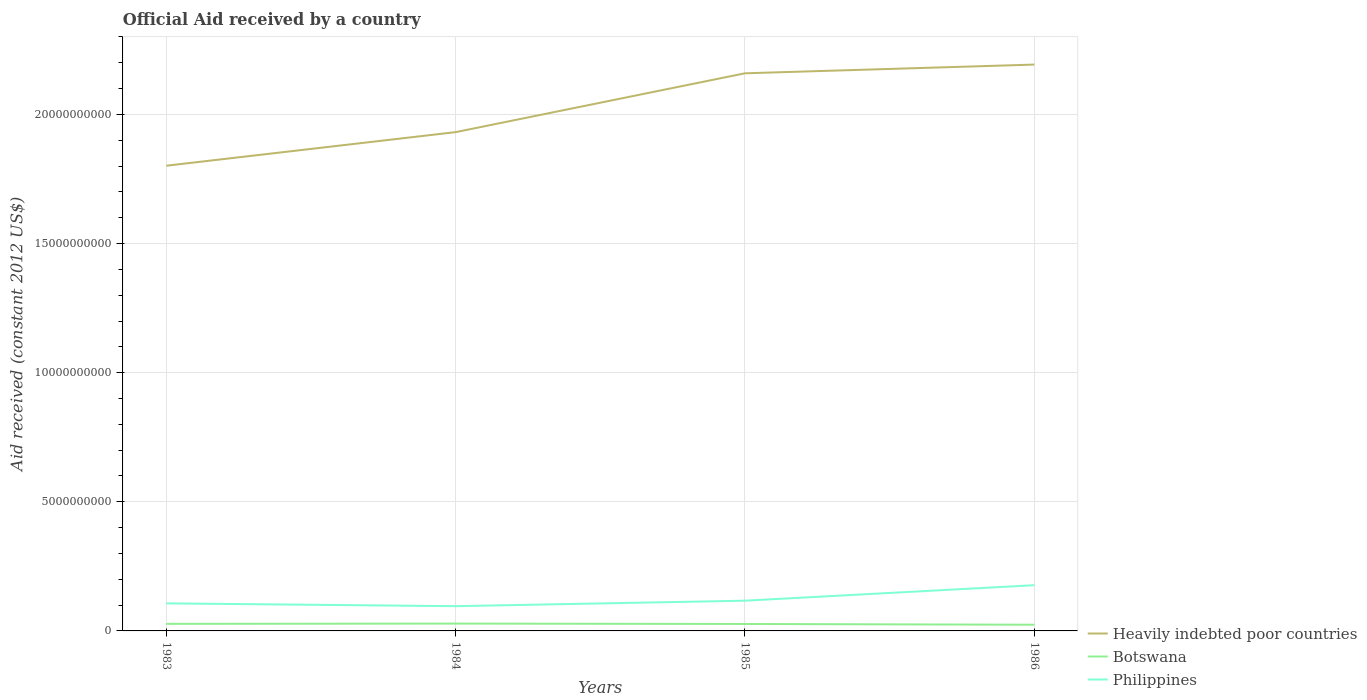Is the number of lines equal to the number of legend labels?
Give a very brief answer. Yes. Across all years, what is the maximum net official aid received in Heavily indebted poor countries?
Offer a terse response. 1.80e+1. What is the total net official aid received in Botswana in the graph?
Give a very brief answer. 3.48e+07. What is the difference between the highest and the second highest net official aid received in Philippines?
Keep it short and to the point. 8.12e+08. What is the difference between the highest and the lowest net official aid received in Heavily indebted poor countries?
Offer a very short reply. 2. What is the difference between two consecutive major ticks on the Y-axis?
Provide a short and direct response. 5.00e+09. Are the values on the major ticks of Y-axis written in scientific E-notation?
Offer a terse response. No. Does the graph contain any zero values?
Make the answer very short. No. Does the graph contain grids?
Your answer should be very brief. Yes. Where does the legend appear in the graph?
Provide a short and direct response. Bottom right. How many legend labels are there?
Your answer should be compact. 3. What is the title of the graph?
Offer a very short reply. Official Aid received by a country. Does "St. Martin (French part)" appear as one of the legend labels in the graph?
Make the answer very short. No. What is the label or title of the Y-axis?
Make the answer very short. Aid received (constant 2012 US$). What is the Aid received (constant 2012 US$) in Heavily indebted poor countries in 1983?
Your answer should be very brief. 1.80e+1. What is the Aid received (constant 2012 US$) in Botswana in 1983?
Provide a succinct answer. 2.74e+08. What is the Aid received (constant 2012 US$) of Philippines in 1983?
Offer a terse response. 1.07e+09. What is the Aid received (constant 2012 US$) of Heavily indebted poor countries in 1984?
Offer a terse response. 1.93e+1. What is the Aid received (constant 2012 US$) in Botswana in 1984?
Offer a very short reply. 2.84e+08. What is the Aid received (constant 2012 US$) in Philippines in 1984?
Provide a short and direct response. 9.58e+08. What is the Aid received (constant 2012 US$) in Heavily indebted poor countries in 1985?
Make the answer very short. 2.16e+1. What is the Aid received (constant 2012 US$) in Botswana in 1985?
Offer a terse response. 2.69e+08. What is the Aid received (constant 2012 US$) in Philippines in 1985?
Your answer should be very brief. 1.17e+09. What is the Aid received (constant 2012 US$) of Heavily indebted poor countries in 1986?
Offer a terse response. 2.19e+1. What is the Aid received (constant 2012 US$) in Botswana in 1986?
Ensure brevity in your answer.  2.39e+08. What is the Aid received (constant 2012 US$) in Philippines in 1986?
Provide a short and direct response. 1.77e+09. Across all years, what is the maximum Aid received (constant 2012 US$) of Heavily indebted poor countries?
Keep it short and to the point. 2.19e+1. Across all years, what is the maximum Aid received (constant 2012 US$) of Botswana?
Your answer should be compact. 2.84e+08. Across all years, what is the maximum Aid received (constant 2012 US$) in Philippines?
Give a very brief answer. 1.77e+09. Across all years, what is the minimum Aid received (constant 2012 US$) of Heavily indebted poor countries?
Your answer should be compact. 1.80e+1. Across all years, what is the minimum Aid received (constant 2012 US$) in Botswana?
Your response must be concise. 2.39e+08. Across all years, what is the minimum Aid received (constant 2012 US$) of Philippines?
Provide a succinct answer. 9.58e+08. What is the total Aid received (constant 2012 US$) in Heavily indebted poor countries in the graph?
Your answer should be compact. 8.08e+1. What is the total Aid received (constant 2012 US$) of Botswana in the graph?
Offer a terse response. 1.07e+09. What is the total Aid received (constant 2012 US$) of Philippines in the graph?
Your answer should be very brief. 4.97e+09. What is the difference between the Aid received (constant 2012 US$) in Heavily indebted poor countries in 1983 and that in 1984?
Make the answer very short. -1.30e+09. What is the difference between the Aid received (constant 2012 US$) in Botswana in 1983 and that in 1984?
Your response must be concise. -1.00e+07. What is the difference between the Aid received (constant 2012 US$) in Philippines in 1983 and that in 1984?
Make the answer very short. 1.09e+08. What is the difference between the Aid received (constant 2012 US$) in Heavily indebted poor countries in 1983 and that in 1985?
Make the answer very short. -3.58e+09. What is the difference between the Aid received (constant 2012 US$) in Botswana in 1983 and that in 1985?
Give a very brief answer. 4.75e+06. What is the difference between the Aid received (constant 2012 US$) in Philippines in 1983 and that in 1985?
Your answer should be compact. -1.03e+08. What is the difference between the Aid received (constant 2012 US$) of Heavily indebted poor countries in 1983 and that in 1986?
Give a very brief answer. -3.92e+09. What is the difference between the Aid received (constant 2012 US$) of Botswana in 1983 and that in 1986?
Ensure brevity in your answer.  3.48e+07. What is the difference between the Aid received (constant 2012 US$) of Philippines in 1983 and that in 1986?
Offer a terse response. -7.03e+08. What is the difference between the Aid received (constant 2012 US$) of Heavily indebted poor countries in 1984 and that in 1985?
Offer a very short reply. -2.28e+09. What is the difference between the Aid received (constant 2012 US$) in Botswana in 1984 and that in 1985?
Your answer should be very brief. 1.48e+07. What is the difference between the Aid received (constant 2012 US$) of Philippines in 1984 and that in 1985?
Make the answer very short. -2.12e+08. What is the difference between the Aid received (constant 2012 US$) of Heavily indebted poor countries in 1984 and that in 1986?
Your response must be concise. -2.62e+09. What is the difference between the Aid received (constant 2012 US$) of Botswana in 1984 and that in 1986?
Ensure brevity in your answer.  4.48e+07. What is the difference between the Aid received (constant 2012 US$) in Philippines in 1984 and that in 1986?
Ensure brevity in your answer.  -8.12e+08. What is the difference between the Aid received (constant 2012 US$) of Heavily indebted poor countries in 1985 and that in 1986?
Provide a succinct answer. -3.37e+08. What is the difference between the Aid received (constant 2012 US$) in Botswana in 1985 and that in 1986?
Make the answer very short. 3.01e+07. What is the difference between the Aid received (constant 2012 US$) of Philippines in 1985 and that in 1986?
Ensure brevity in your answer.  -6.00e+08. What is the difference between the Aid received (constant 2012 US$) in Heavily indebted poor countries in 1983 and the Aid received (constant 2012 US$) in Botswana in 1984?
Your answer should be compact. 1.77e+1. What is the difference between the Aid received (constant 2012 US$) of Heavily indebted poor countries in 1983 and the Aid received (constant 2012 US$) of Philippines in 1984?
Offer a terse response. 1.71e+1. What is the difference between the Aid received (constant 2012 US$) of Botswana in 1983 and the Aid received (constant 2012 US$) of Philippines in 1984?
Give a very brief answer. -6.84e+08. What is the difference between the Aid received (constant 2012 US$) of Heavily indebted poor countries in 1983 and the Aid received (constant 2012 US$) of Botswana in 1985?
Keep it short and to the point. 1.77e+1. What is the difference between the Aid received (constant 2012 US$) of Heavily indebted poor countries in 1983 and the Aid received (constant 2012 US$) of Philippines in 1985?
Your response must be concise. 1.68e+1. What is the difference between the Aid received (constant 2012 US$) in Botswana in 1983 and the Aid received (constant 2012 US$) in Philippines in 1985?
Offer a terse response. -8.96e+08. What is the difference between the Aid received (constant 2012 US$) in Heavily indebted poor countries in 1983 and the Aid received (constant 2012 US$) in Botswana in 1986?
Provide a short and direct response. 1.78e+1. What is the difference between the Aid received (constant 2012 US$) of Heavily indebted poor countries in 1983 and the Aid received (constant 2012 US$) of Philippines in 1986?
Give a very brief answer. 1.62e+1. What is the difference between the Aid received (constant 2012 US$) in Botswana in 1983 and the Aid received (constant 2012 US$) in Philippines in 1986?
Your response must be concise. -1.50e+09. What is the difference between the Aid received (constant 2012 US$) of Heavily indebted poor countries in 1984 and the Aid received (constant 2012 US$) of Botswana in 1985?
Make the answer very short. 1.90e+1. What is the difference between the Aid received (constant 2012 US$) of Heavily indebted poor countries in 1984 and the Aid received (constant 2012 US$) of Philippines in 1985?
Give a very brief answer. 1.81e+1. What is the difference between the Aid received (constant 2012 US$) of Botswana in 1984 and the Aid received (constant 2012 US$) of Philippines in 1985?
Your answer should be compact. -8.86e+08. What is the difference between the Aid received (constant 2012 US$) of Heavily indebted poor countries in 1984 and the Aid received (constant 2012 US$) of Botswana in 1986?
Provide a succinct answer. 1.91e+1. What is the difference between the Aid received (constant 2012 US$) in Heavily indebted poor countries in 1984 and the Aid received (constant 2012 US$) in Philippines in 1986?
Offer a terse response. 1.75e+1. What is the difference between the Aid received (constant 2012 US$) of Botswana in 1984 and the Aid received (constant 2012 US$) of Philippines in 1986?
Offer a terse response. -1.49e+09. What is the difference between the Aid received (constant 2012 US$) in Heavily indebted poor countries in 1985 and the Aid received (constant 2012 US$) in Botswana in 1986?
Ensure brevity in your answer.  2.14e+1. What is the difference between the Aid received (constant 2012 US$) of Heavily indebted poor countries in 1985 and the Aid received (constant 2012 US$) of Philippines in 1986?
Offer a very short reply. 1.98e+1. What is the difference between the Aid received (constant 2012 US$) of Botswana in 1985 and the Aid received (constant 2012 US$) of Philippines in 1986?
Offer a terse response. -1.50e+09. What is the average Aid received (constant 2012 US$) of Heavily indebted poor countries per year?
Make the answer very short. 2.02e+1. What is the average Aid received (constant 2012 US$) in Botswana per year?
Provide a short and direct response. 2.67e+08. What is the average Aid received (constant 2012 US$) of Philippines per year?
Offer a terse response. 1.24e+09. In the year 1983, what is the difference between the Aid received (constant 2012 US$) of Heavily indebted poor countries and Aid received (constant 2012 US$) of Botswana?
Provide a short and direct response. 1.77e+1. In the year 1983, what is the difference between the Aid received (constant 2012 US$) of Heavily indebted poor countries and Aid received (constant 2012 US$) of Philippines?
Give a very brief answer. 1.69e+1. In the year 1983, what is the difference between the Aid received (constant 2012 US$) in Botswana and Aid received (constant 2012 US$) in Philippines?
Give a very brief answer. -7.93e+08. In the year 1984, what is the difference between the Aid received (constant 2012 US$) of Heavily indebted poor countries and Aid received (constant 2012 US$) of Botswana?
Offer a very short reply. 1.90e+1. In the year 1984, what is the difference between the Aid received (constant 2012 US$) in Heavily indebted poor countries and Aid received (constant 2012 US$) in Philippines?
Provide a succinct answer. 1.84e+1. In the year 1984, what is the difference between the Aid received (constant 2012 US$) in Botswana and Aid received (constant 2012 US$) in Philippines?
Offer a very short reply. -6.74e+08. In the year 1985, what is the difference between the Aid received (constant 2012 US$) in Heavily indebted poor countries and Aid received (constant 2012 US$) in Botswana?
Ensure brevity in your answer.  2.13e+1. In the year 1985, what is the difference between the Aid received (constant 2012 US$) of Heavily indebted poor countries and Aid received (constant 2012 US$) of Philippines?
Provide a short and direct response. 2.04e+1. In the year 1985, what is the difference between the Aid received (constant 2012 US$) of Botswana and Aid received (constant 2012 US$) of Philippines?
Ensure brevity in your answer.  -9.01e+08. In the year 1986, what is the difference between the Aid received (constant 2012 US$) in Heavily indebted poor countries and Aid received (constant 2012 US$) in Botswana?
Your answer should be very brief. 2.17e+1. In the year 1986, what is the difference between the Aid received (constant 2012 US$) in Heavily indebted poor countries and Aid received (constant 2012 US$) in Philippines?
Your answer should be very brief. 2.02e+1. In the year 1986, what is the difference between the Aid received (constant 2012 US$) of Botswana and Aid received (constant 2012 US$) of Philippines?
Your answer should be compact. -1.53e+09. What is the ratio of the Aid received (constant 2012 US$) of Heavily indebted poor countries in 1983 to that in 1984?
Ensure brevity in your answer.  0.93. What is the ratio of the Aid received (constant 2012 US$) in Botswana in 1983 to that in 1984?
Make the answer very short. 0.96. What is the ratio of the Aid received (constant 2012 US$) of Philippines in 1983 to that in 1984?
Make the answer very short. 1.11. What is the ratio of the Aid received (constant 2012 US$) of Heavily indebted poor countries in 1983 to that in 1985?
Your answer should be very brief. 0.83. What is the ratio of the Aid received (constant 2012 US$) of Botswana in 1983 to that in 1985?
Your answer should be very brief. 1.02. What is the ratio of the Aid received (constant 2012 US$) in Philippines in 1983 to that in 1985?
Provide a short and direct response. 0.91. What is the ratio of the Aid received (constant 2012 US$) of Heavily indebted poor countries in 1983 to that in 1986?
Give a very brief answer. 0.82. What is the ratio of the Aid received (constant 2012 US$) in Botswana in 1983 to that in 1986?
Provide a succinct answer. 1.15. What is the ratio of the Aid received (constant 2012 US$) in Philippines in 1983 to that in 1986?
Give a very brief answer. 0.6. What is the ratio of the Aid received (constant 2012 US$) in Heavily indebted poor countries in 1984 to that in 1985?
Keep it short and to the point. 0.89. What is the ratio of the Aid received (constant 2012 US$) in Botswana in 1984 to that in 1985?
Keep it short and to the point. 1.05. What is the ratio of the Aid received (constant 2012 US$) in Philippines in 1984 to that in 1985?
Give a very brief answer. 0.82. What is the ratio of the Aid received (constant 2012 US$) in Heavily indebted poor countries in 1984 to that in 1986?
Your answer should be compact. 0.88. What is the ratio of the Aid received (constant 2012 US$) of Botswana in 1984 to that in 1986?
Your answer should be compact. 1.19. What is the ratio of the Aid received (constant 2012 US$) in Philippines in 1984 to that in 1986?
Give a very brief answer. 0.54. What is the ratio of the Aid received (constant 2012 US$) of Heavily indebted poor countries in 1985 to that in 1986?
Provide a succinct answer. 0.98. What is the ratio of the Aid received (constant 2012 US$) of Botswana in 1985 to that in 1986?
Offer a terse response. 1.13. What is the ratio of the Aid received (constant 2012 US$) of Philippines in 1985 to that in 1986?
Give a very brief answer. 0.66. What is the difference between the highest and the second highest Aid received (constant 2012 US$) in Heavily indebted poor countries?
Make the answer very short. 3.37e+08. What is the difference between the highest and the second highest Aid received (constant 2012 US$) in Botswana?
Your answer should be very brief. 1.00e+07. What is the difference between the highest and the second highest Aid received (constant 2012 US$) of Philippines?
Your answer should be compact. 6.00e+08. What is the difference between the highest and the lowest Aid received (constant 2012 US$) of Heavily indebted poor countries?
Make the answer very short. 3.92e+09. What is the difference between the highest and the lowest Aid received (constant 2012 US$) of Botswana?
Your answer should be compact. 4.48e+07. What is the difference between the highest and the lowest Aid received (constant 2012 US$) in Philippines?
Your answer should be compact. 8.12e+08. 